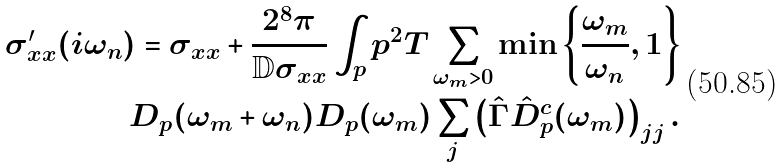Convert formula to latex. <formula><loc_0><loc_0><loc_500><loc_500>\sigma ^ { \prime } _ { x x } ( i \omega _ { n } ) = \sigma _ { x x } + \frac { 2 ^ { 8 } \pi } { \mathbb { D } \sigma _ { x x } } \int _ { p } p ^ { 2 } T \sum _ { \omega _ { m } > 0 } \min \left \{ \frac { \omega _ { m } } { \omega _ { n } } , 1 \right \} \\ D _ { p } ( \omega _ { m } + \omega _ { n } ) D _ { p } ( \omega _ { m } ) \sum _ { j } \left ( \hat { \Gamma } \hat { D } ^ { c } _ { p } ( \omega _ { m } ) \right ) _ { j j } .</formula> 